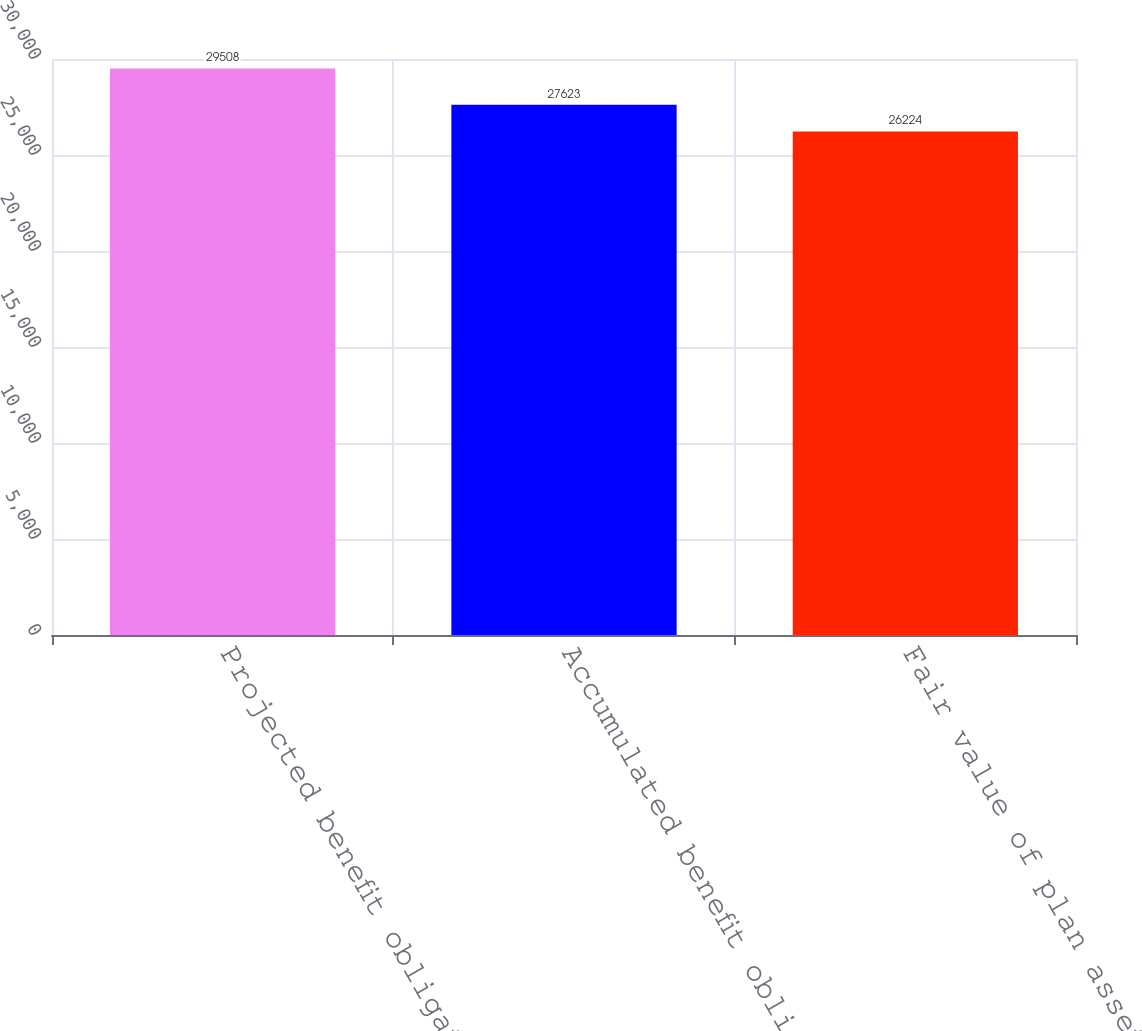Convert chart to OTSL. <chart><loc_0><loc_0><loc_500><loc_500><bar_chart><fcel>Projected benefit obligation<fcel>Accumulated benefit obligation<fcel>Fair value of plan assets<nl><fcel>29508<fcel>27623<fcel>26224<nl></chart> 